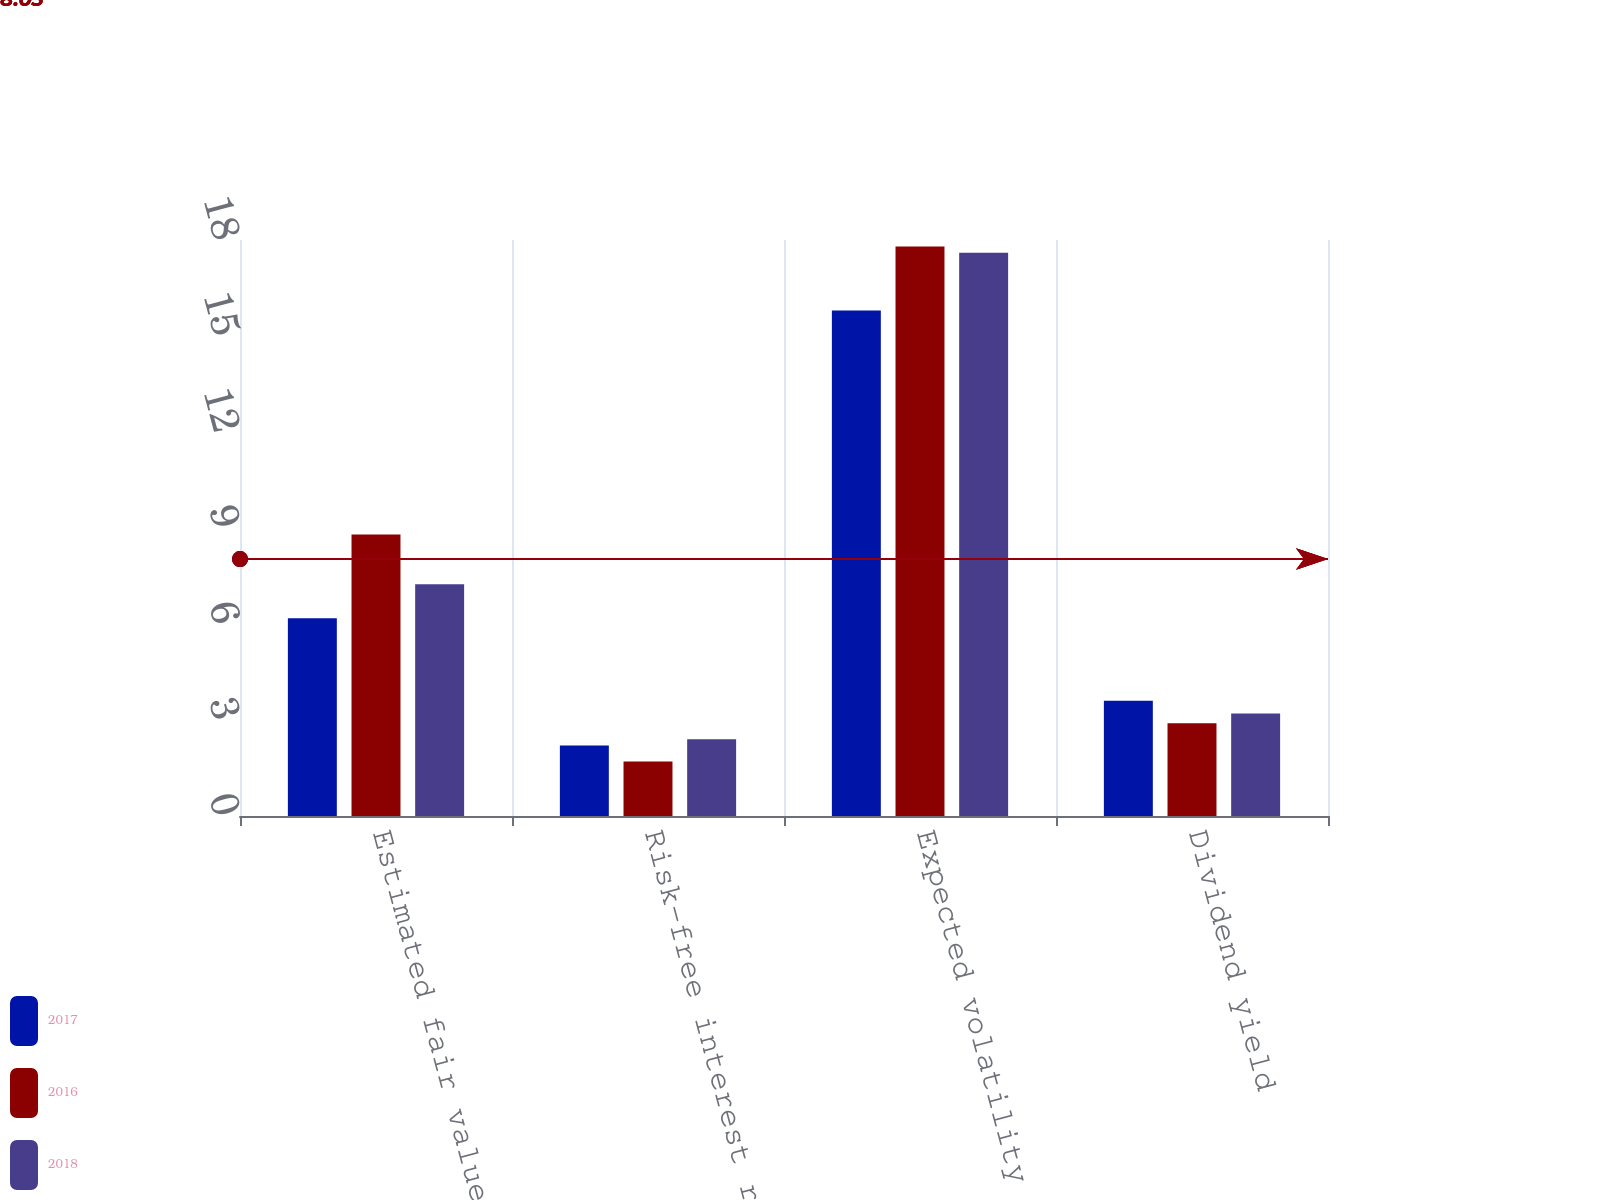Convert chart to OTSL. <chart><loc_0><loc_0><loc_500><loc_500><stacked_bar_chart><ecel><fcel>Estimated fair values of stock<fcel>Risk-free interest rate<fcel>Expected volatility<fcel>Dividend yield<nl><fcel>2017<fcel>6.18<fcel>2.2<fcel>15.8<fcel>3.6<nl><fcel>2016<fcel>8.8<fcel>1.7<fcel>17.8<fcel>2.9<nl><fcel>2018<fcel>7.24<fcel>2.4<fcel>17.6<fcel>3.2<nl></chart> 